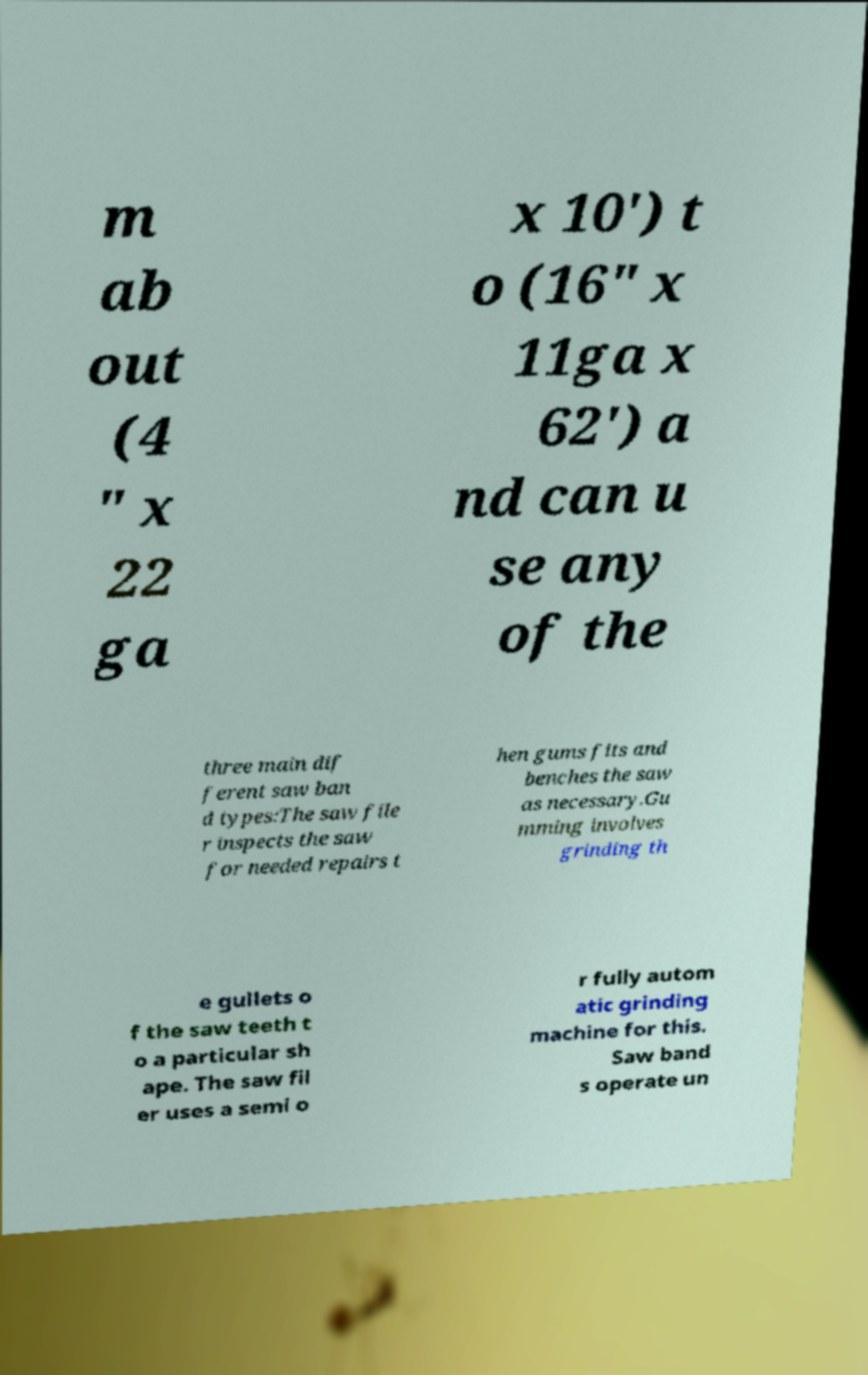I need the written content from this picture converted into text. Can you do that? m ab out (4 " x 22 ga x 10') t o (16" x 11ga x 62') a nd can u se any of the three main dif ferent saw ban d types:The saw file r inspects the saw for needed repairs t hen gums fits and benches the saw as necessary.Gu mming involves grinding th e gullets o f the saw teeth t o a particular sh ape. The saw fil er uses a semi o r fully autom atic grinding machine for this. Saw band s operate un 